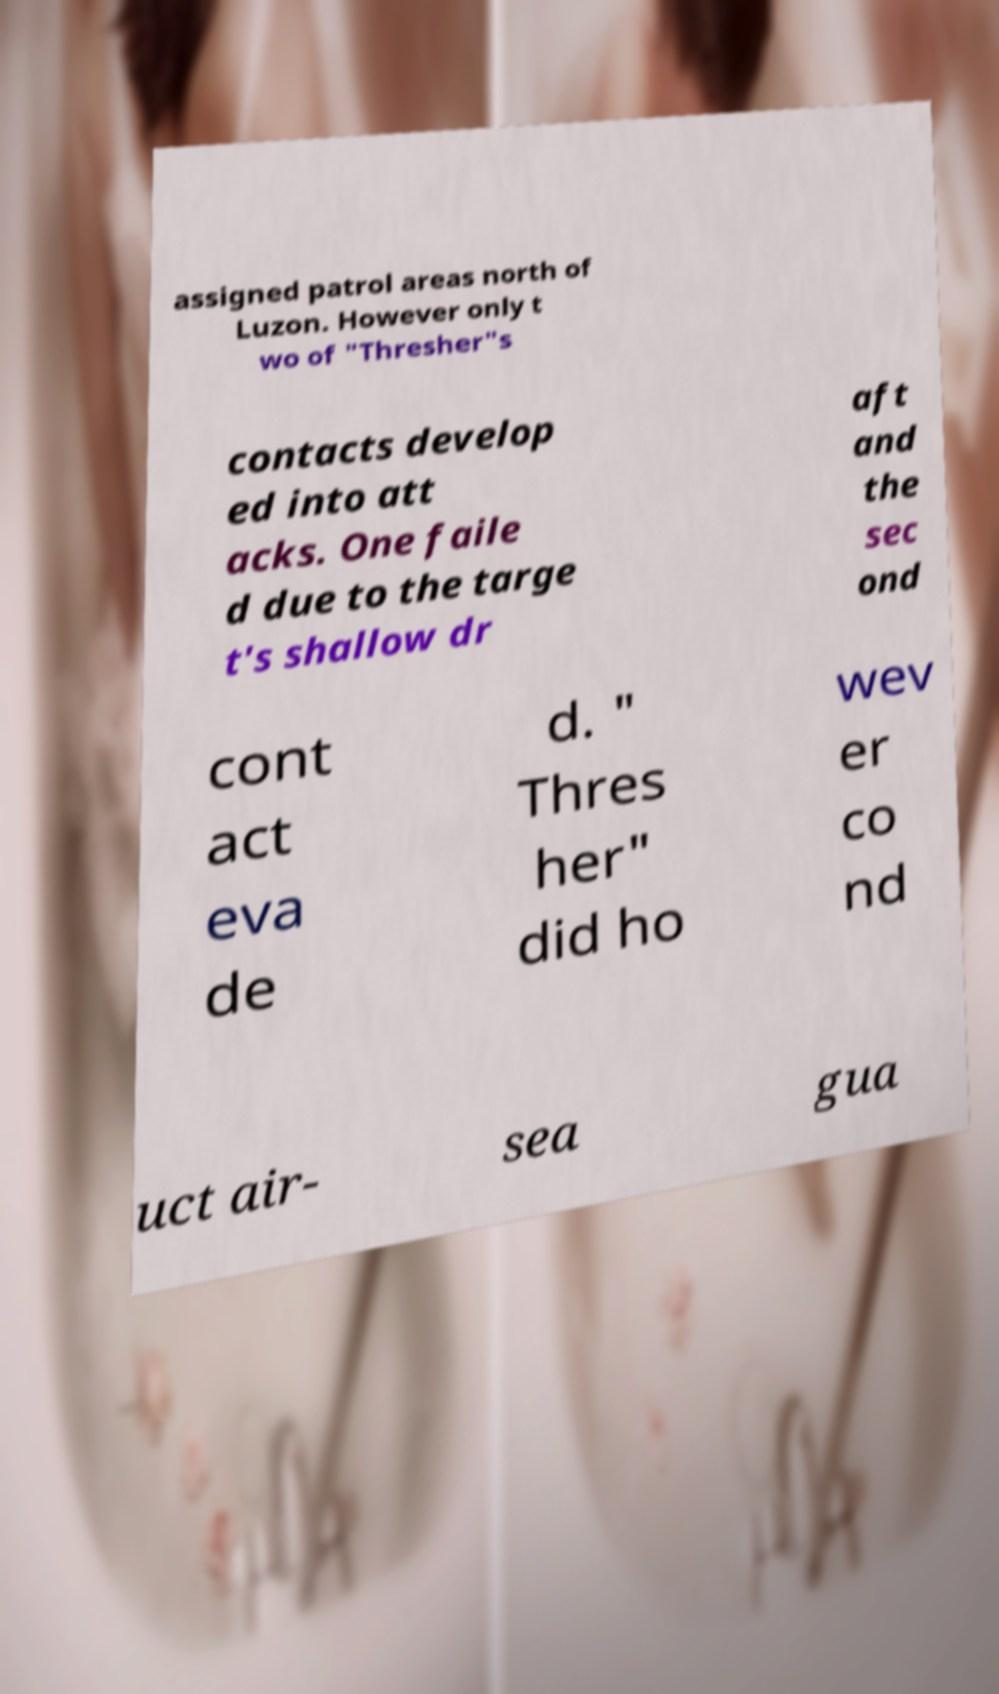There's text embedded in this image that I need extracted. Can you transcribe it verbatim? assigned patrol areas north of Luzon. However only t wo of "Thresher"s contacts develop ed into att acks. One faile d due to the targe t's shallow dr aft and the sec ond cont act eva de d. " Thres her" did ho wev er co nd uct air- sea gua 